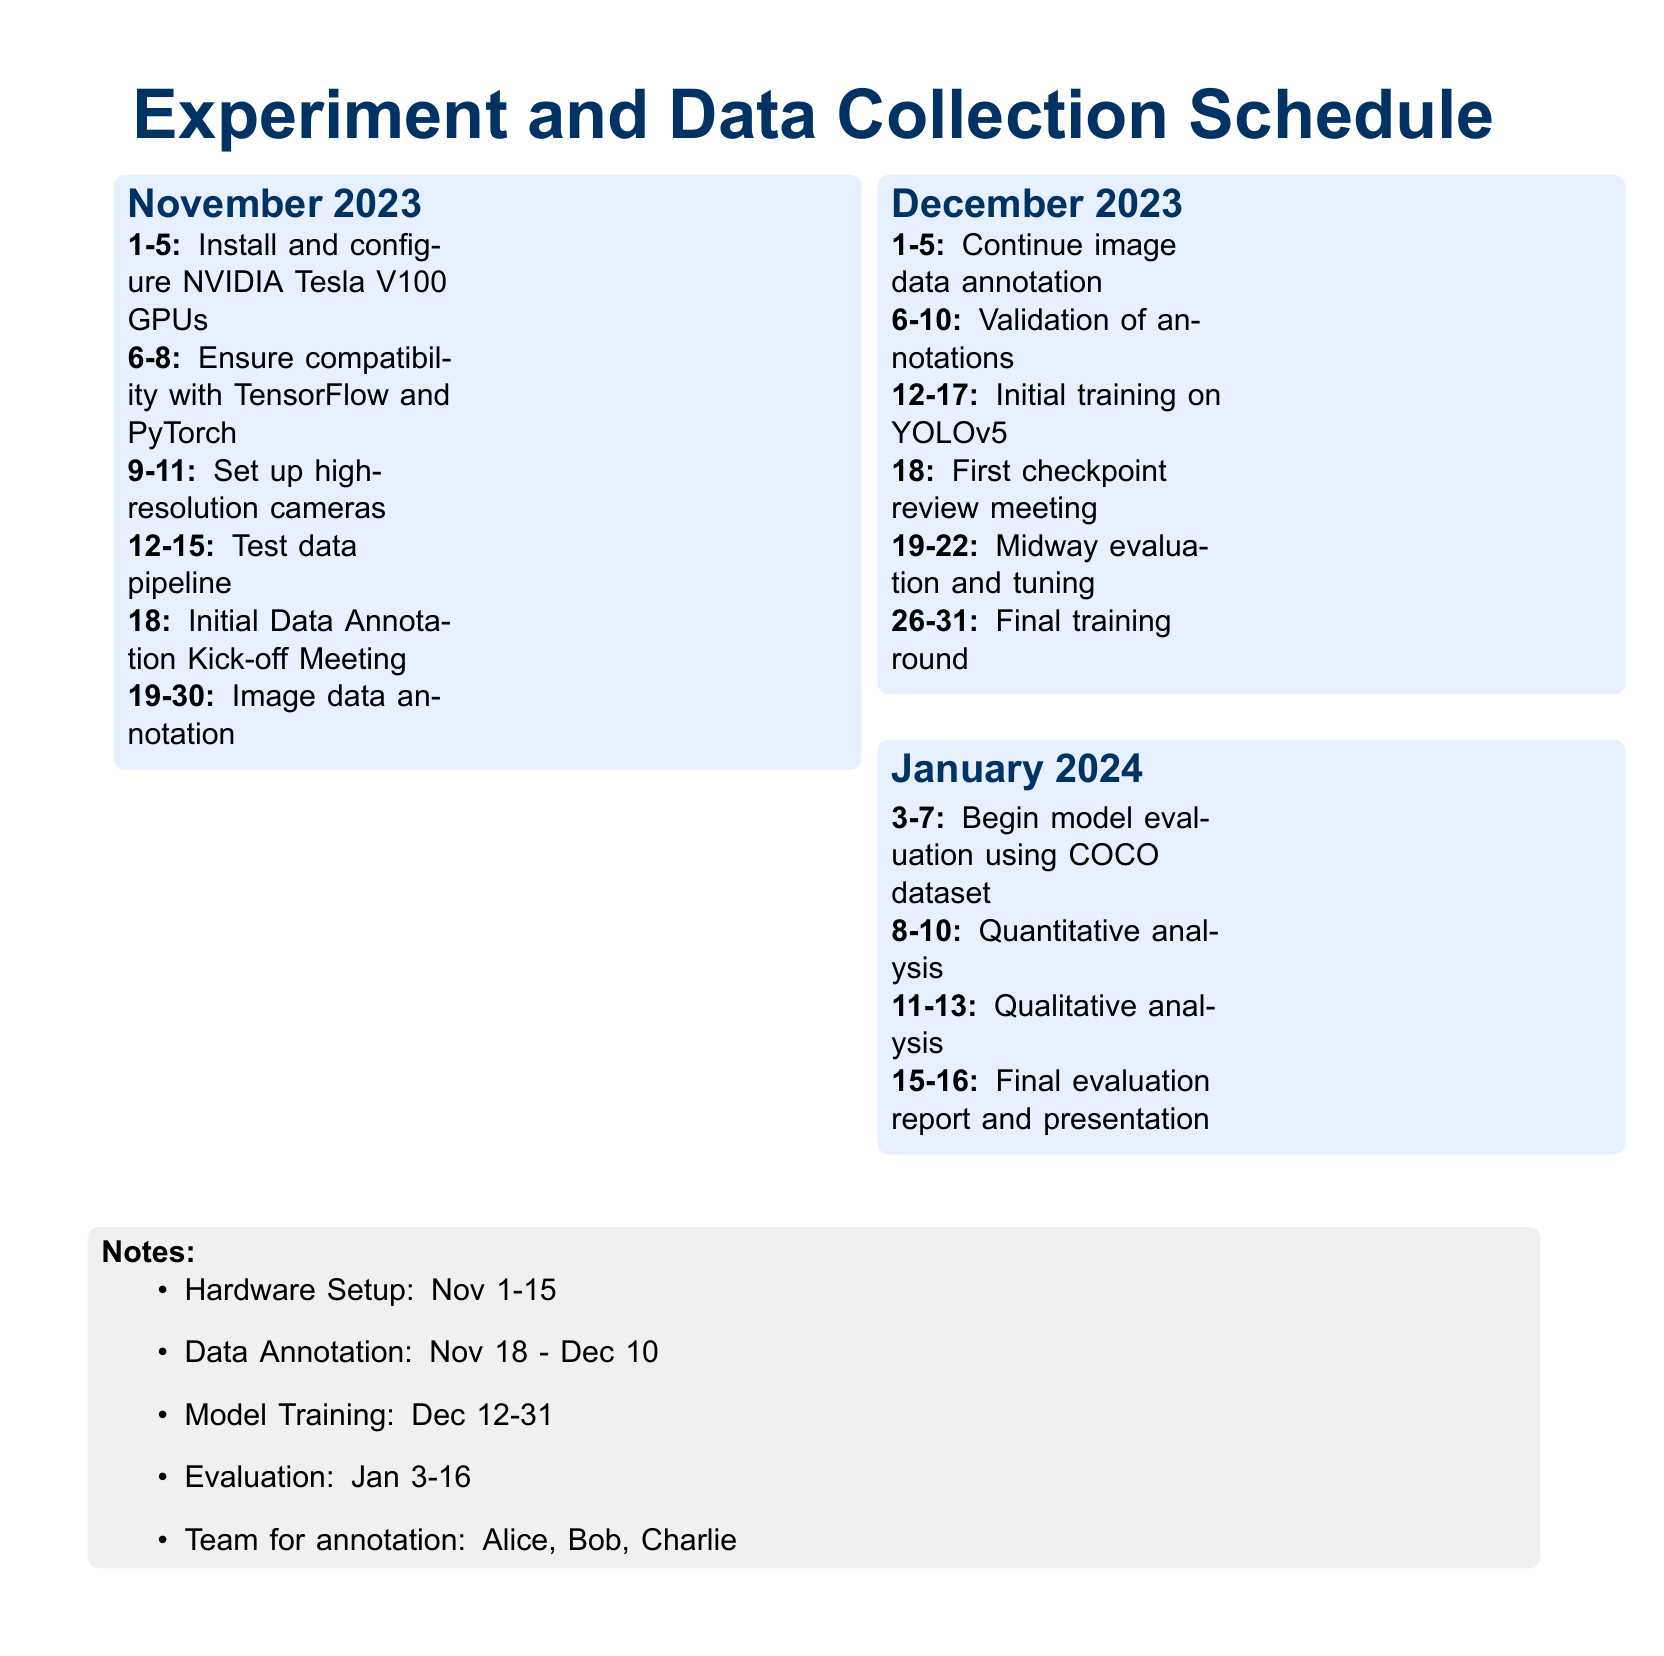What is the start date for hardware setup? The hardware setup starts on November 1, 2023, as listed in the document.
Answer: November 1 Who is responsible for data annotation? The document lists Alice, Bob, and Charlie as the team for annotation.
Answer: Alice, Bob, Charlie When is the first checkpoint review meeting scheduled? The first checkpoint review meeting is scheduled on December 18, 2023.
Answer: December 18 How many days are dedicated to image data annotation? The annotation sessions run from November 19 to December 10, totaling 22 days.
Answer: 22 days What is the end date for model training? The final training round is set to end on December 31, 2023.
Answer: December 31 What analysis occurs between January 8-10? During these days, quantitative analysis is scheduled as stated in the document.
Answer: Quantitative analysis Which month has the initial training on YOLOv5? The document states that the initial training on YOLOv5 occurs in December.
Answer: December What is the purpose of the initial Data Annotation Kick-off Meeting? It marks the beginning of the data annotation process as noted on November 18.
Answer: Data annotation kick-off When does the final evaluation report and presentation take place? The final evaluation report and presentation are scheduled for January 15-16, 2024.
Answer: January 15-16 